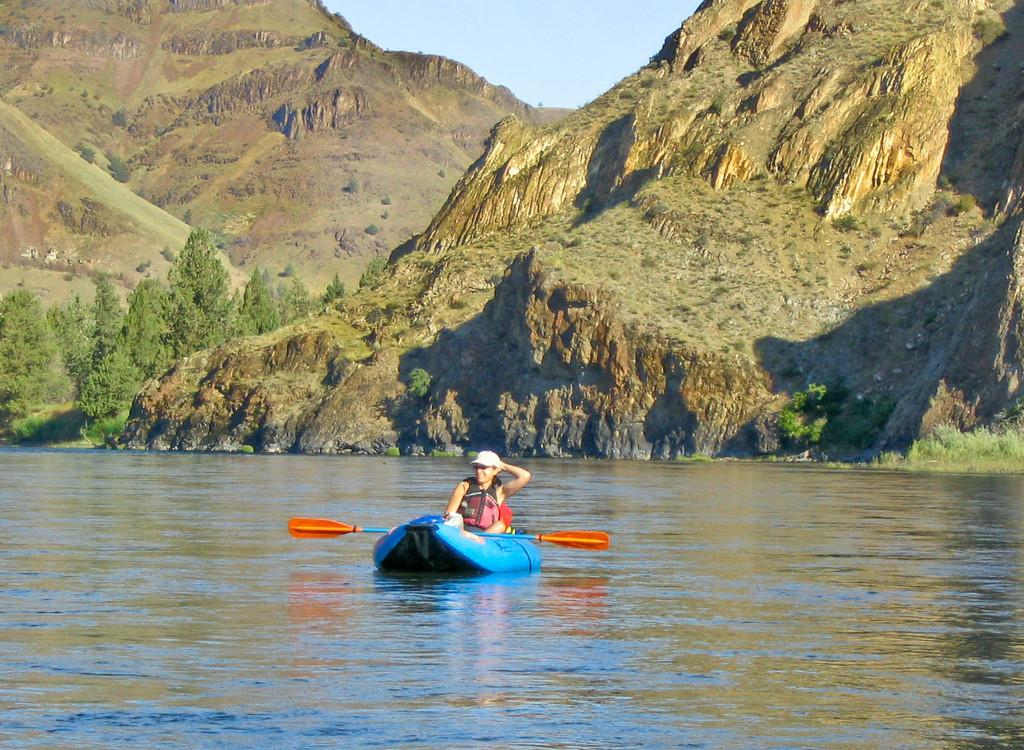What is the main subject of the image? The main subject of the image is a boat. What can be seen in the boat? There is a paddle in the image. What is the woman doing in the image? There is a woman on the surface of the water. What can be seen in the background of the image? Mountains, trees, and the sky are visible in the background of the image. How much does the weight of the mice affect the boat's stability in the image? There are no mice present in the image, so their weight cannot affect the boat's stability. What type of growth can be seen on the trees in the image? There is no indication of growth on the trees in the image; we can only see their general shape and size. 